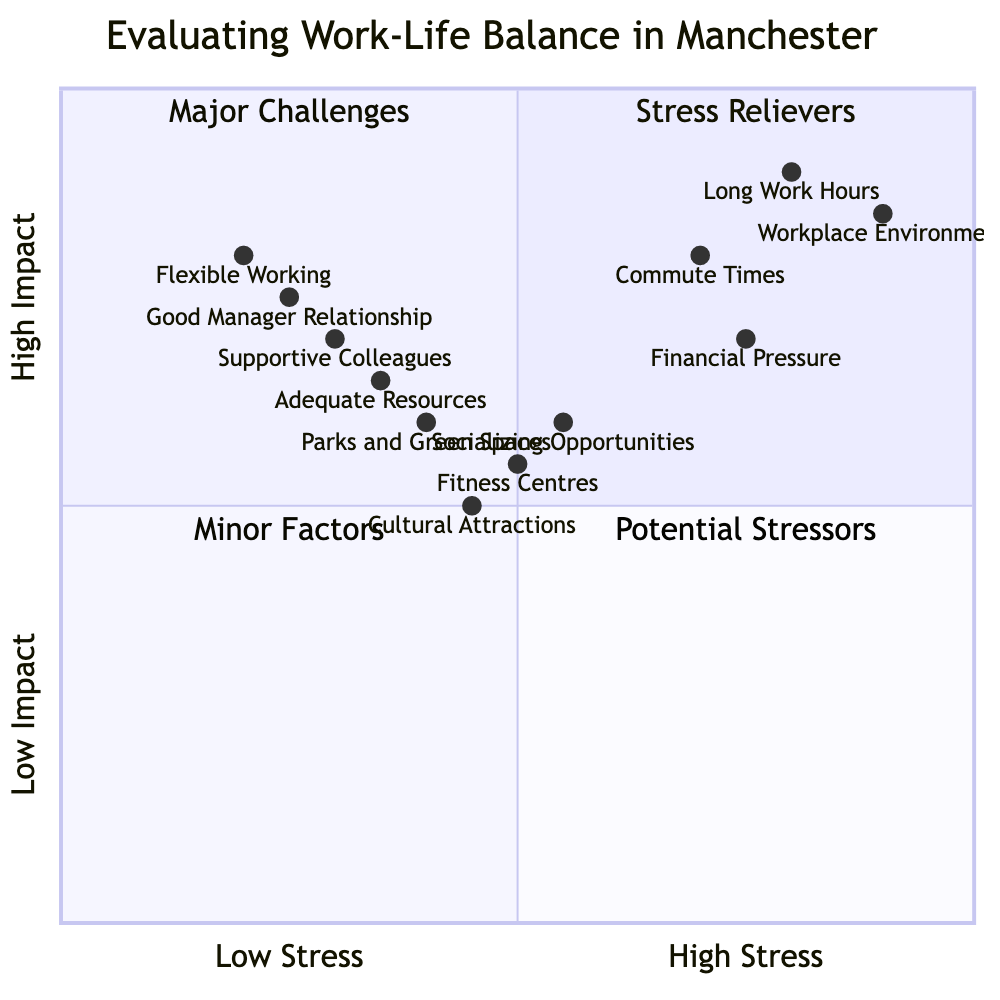What are the coordinates of "Long Work Hours"? The coordinates for "Long Work Hours" are provided in the diagram as [0.8, 0.9]. This indicates its position on the quadrant chart, with a high stress factor and high impact.
Answer: [0.8, 0.9] Which factor is in the "Stress Relievers" quadrant and has a low stress level? "Flexible Working Arrangements" is in the "Stress Relievers" quadrant with coordinates [0.2, 0.8], indicating it has a low stress level and a high impact on reducing stress.
Answer: Flexible Working Arrangements How many factors are classified as "Major Challenges"? There are four factors classified as "Major Challenges." These include "Long Work Hours," "Commute Times," "Workplace Environment," and "Financial Pressure."
Answer: 4 Which relaxation activity is closest to the "Minor Factors" quadrant? "Fitness Centres" is the relaxation activity closest to the "Minor Factors" quadrant with coordinates [0.5, 0.55]. This position indicates a medium stress level and low impact on relaxation.
Answer: Fitness Centres Compare "Workplace Environment" and "Supportive Colleagues" in terms of stress level. "Workplace Environment" shows a higher stress level with coordinates [0.9, 0.85] compared to "Supportive Colleagues," which has coordinates [0.3, 0.7]. This means the workplace environment is a much larger stress factor than supportive colleagues.
Answer: Workplace Environment What is the highest impact factor classified as a potential stressor? "Workplace Environment" has the highest impact in the "Potential Stressors" category with a score of 0.85, indicating it greatly affects overall stress levels.
Answer: Workplace Environment Which cultural attraction has a lower impact than socializing opportunities? "Cultural Attractions" has a lower impact than "Socializing Opportunities," with coordinates [0.45, 0.5] compared to [0.55, 0.6]. This means the former provides less stress relief than socializing.
Answer: Cultural Attractions Identify one factor related to financial pressure. "Financial Pressure" is specifically identified as a factor that contributes to stress, situated in the "Major Challenges" quadrant.
Answer: Financial Pressure Which quadrant contains the majority of the high stress factors? The "Major Challenges" quadrant contains the majority of the high stress factors, including "Long Work Hours," "Commute Times," "Workplace Environment," and "Financial Pressure."
Answer: Major Challenges 